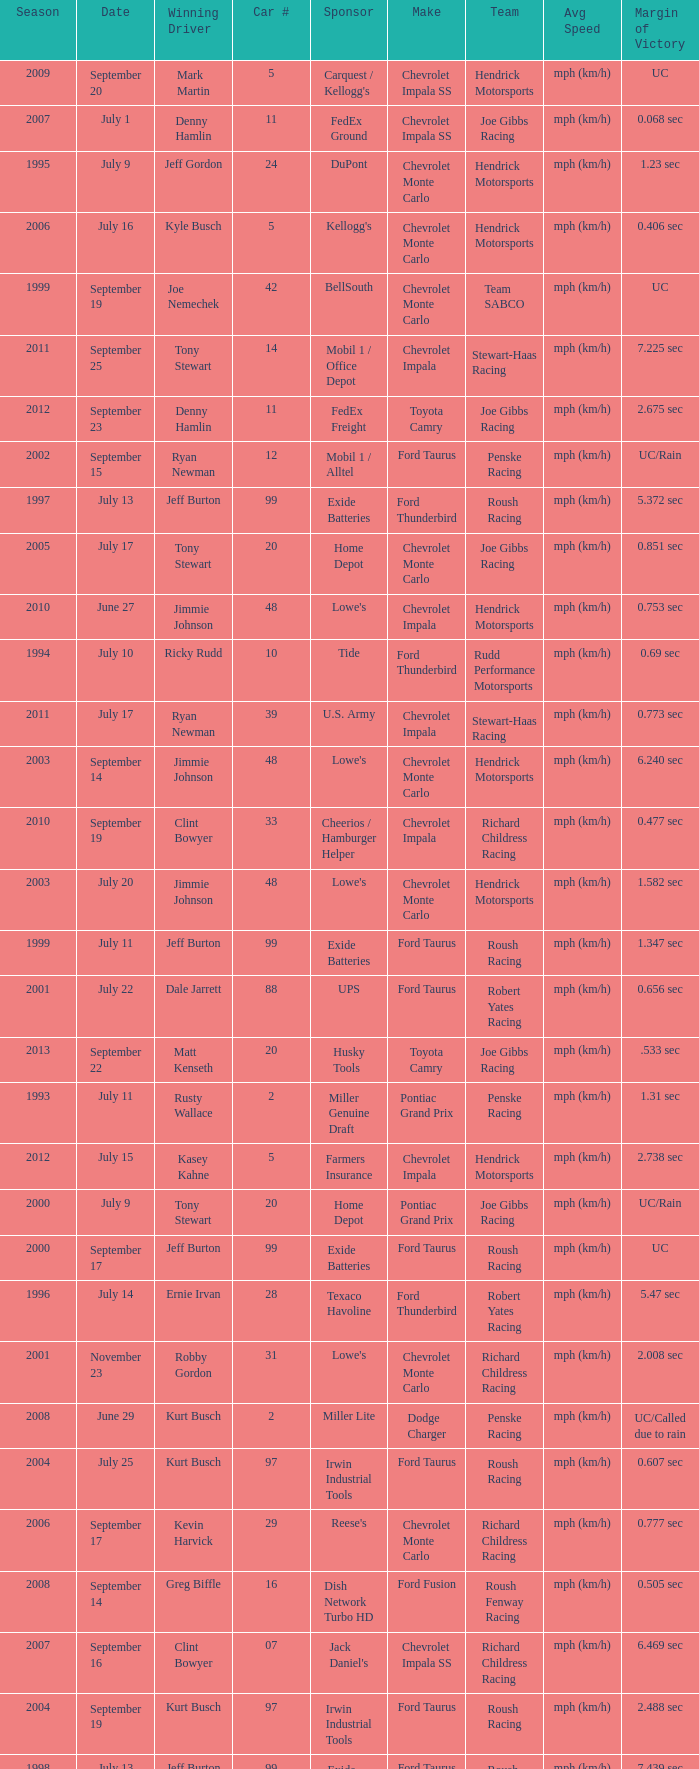What team ran car #24 on August 30? Hendrick Motorsports. 